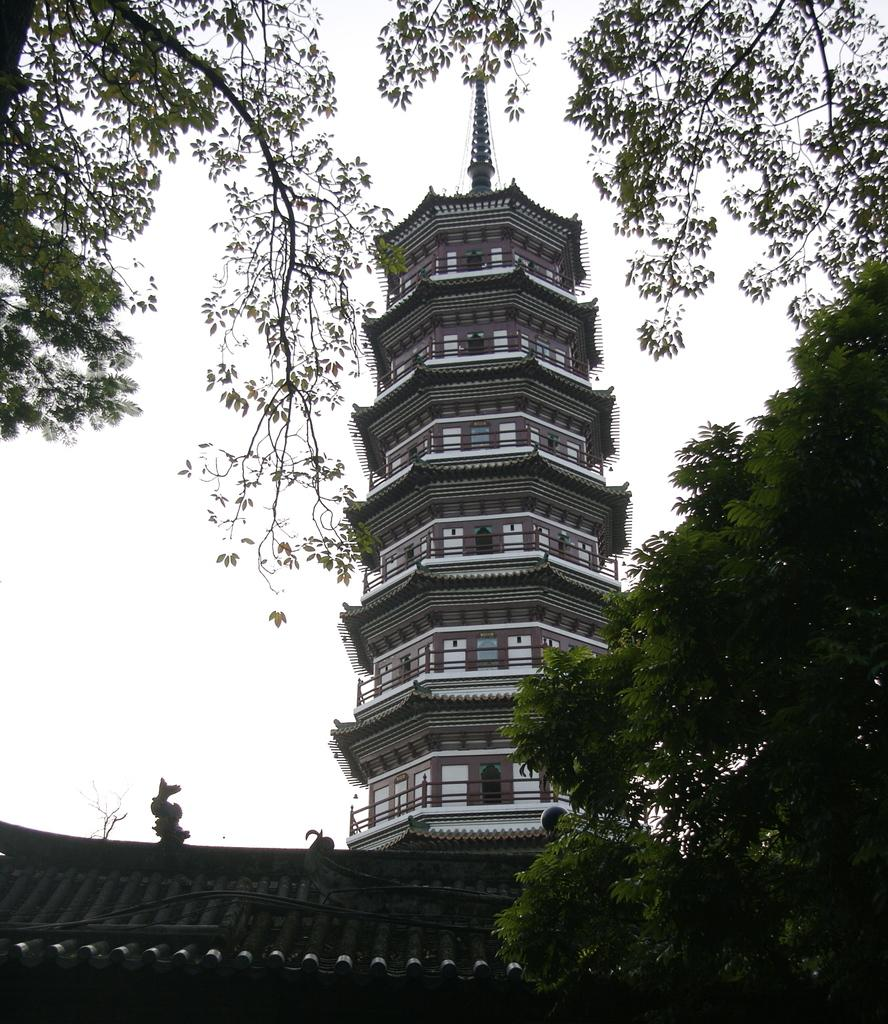What is the main structure located in the middle of the image? There is a tower in the middle of the image. What type of vegetation can be seen in the image? There are trees visible in the image. What part of the natural environment is visible in the image? The sky is visible in the middle of the image. What type of bone can be seen in the image? There is no bone present in the image. What type of pies are being served in the image? There is no reference to pies in the image. 